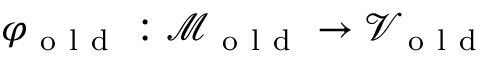Convert formula to latex. <formula><loc_0><loc_0><loc_500><loc_500>\varphi _ { o l d } \colon \mathcal { M } _ { o l d } \to \mathcal { V } _ { o l d }</formula> 